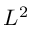Convert formula to latex. <formula><loc_0><loc_0><loc_500><loc_500>L ^ { 2 }</formula> 